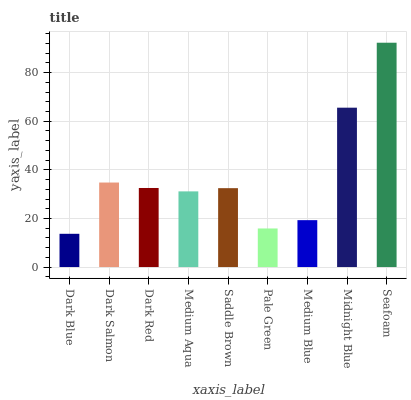Is Dark Blue the minimum?
Answer yes or no. Yes. Is Seafoam the maximum?
Answer yes or no. Yes. Is Dark Salmon the minimum?
Answer yes or no. No. Is Dark Salmon the maximum?
Answer yes or no. No. Is Dark Salmon greater than Dark Blue?
Answer yes or no. Yes. Is Dark Blue less than Dark Salmon?
Answer yes or no. Yes. Is Dark Blue greater than Dark Salmon?
Answer yes or no. No. Is Dark Salmon less than Dark Blue?
Answer yes or no. No. Is Saddle Brown the high median?
Answer yes or no. Yes. Is Saddle Brown the low median?
Answer yes or no. Yes. Is Seafoam the high median?
Answer yes or no. No. Is Pale Green the low median?
Answer yes or no. No. 